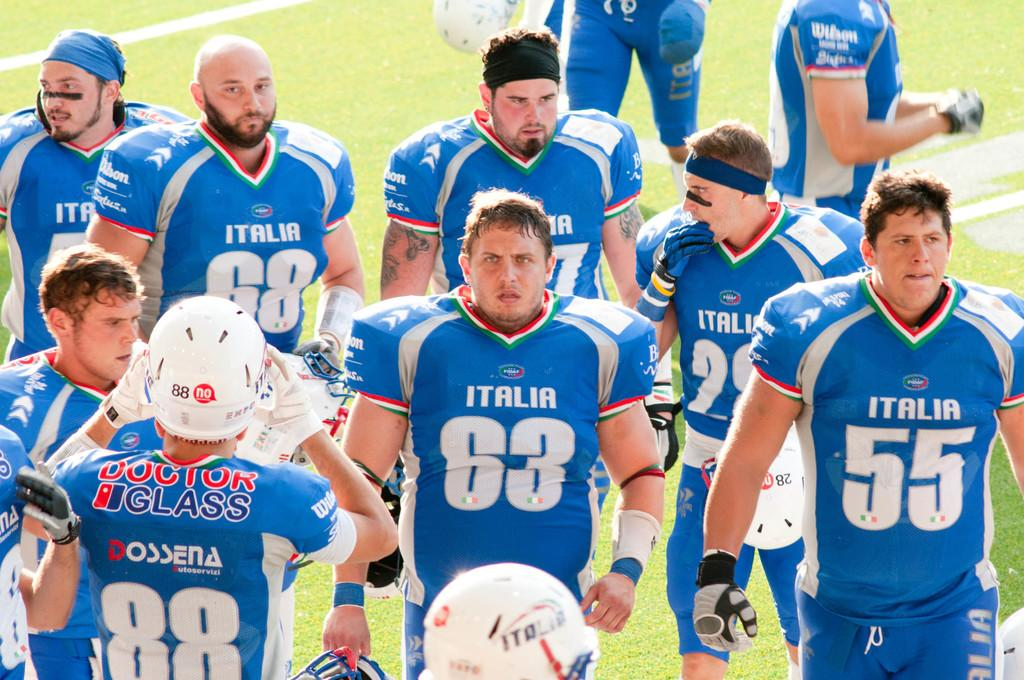<image>
Present a compact description of the photo's key features. A football team from Italia stand on the field 